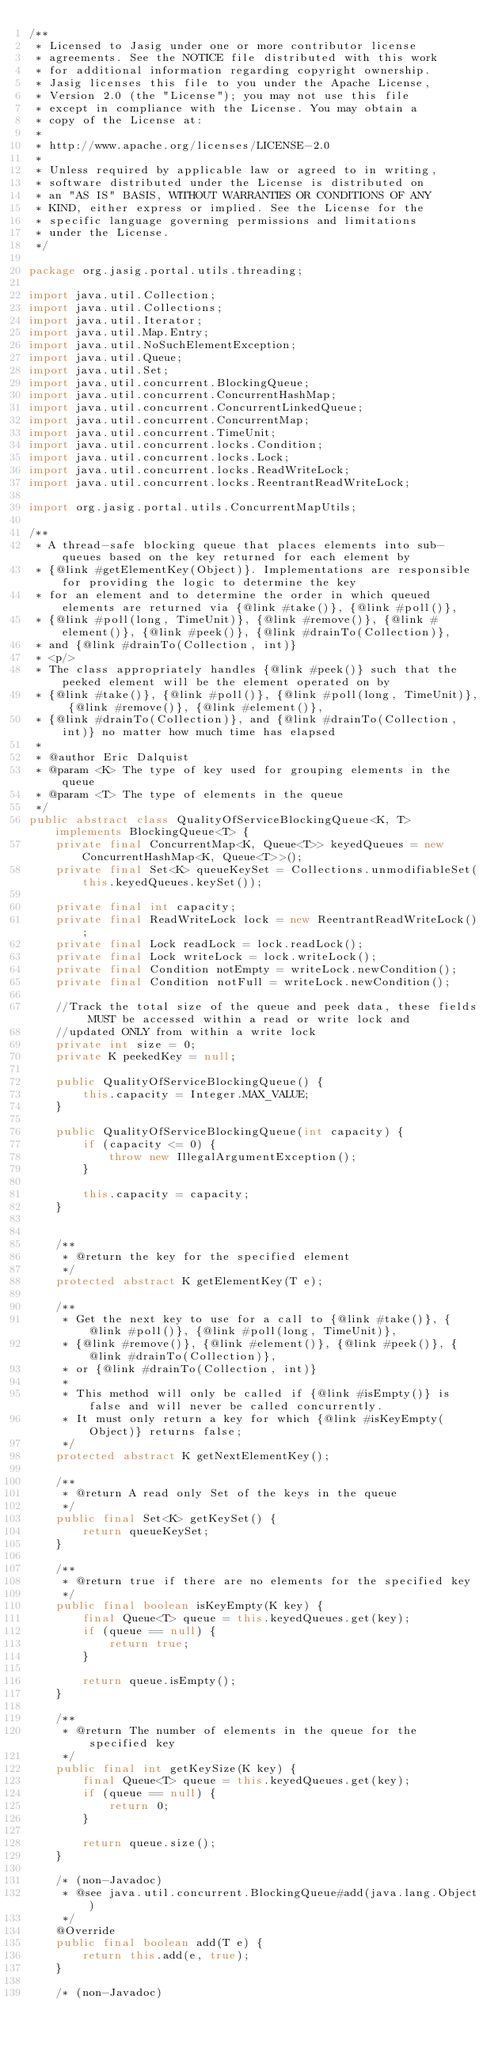<code> <loc_0><loc_0><loc_500><loc_500><_Java_>/**
 * Licensed to Jasig under one or more contributor license
 * agreements. See the NOTICE file distributed with this work
 * for additional information regarding copyright ownership.
 * Jasig licenses this file to you under the Apache License,
 * Version 2.0 (the "License"); you may not use this file
 * except in compliance with the License. You may obtain a
 * copy of the License at:
 *
 * http://www.apache.org/licenses/LICENSE-2.0
 *
 * Unless required by applicable law or agreed to in writing,
 * software distributed under the License is distributed on
 * an "AS IS" BASIS, WITHOUT WARRANTIES OR CONDITIONS OF ANY
 * KIND, either express or implied. See the License for the
 * specific language governing permissions and limitations
 * under the License.
 */

package org.jasig.portal.utils.threading;

import java.util.Collection;
import java.util.Collections;
import java.util.Iterator;
import java.util.Map.Entry;
import java.util.NoSuchElementException;
import java.util.Queue;
import java.util.Set;
import java.util.concurrent.BlockingQueue;
import java.util.concurrent.ConcurrentHashMap;
import java.util.concurrent.ConcurrentLinkedQueue;
import java.util.concurrent.ConcurrentMap;
import java.util.concurrent.TimeUnit;
import java.util.concurrent.locks.Condition;
import java.util.concurrent.locks.Lock;
import java.util.concurrent.locks.ReadWriteLock;
import java.util.concurrent.locks.ReentrantReadWriteLock;

import org.jasig.portal.utils.ConcurrentMapUtils;

/**
 * A thread-safe blocking queue that places elements into sub-queues based on the key returned for each element by
 * {@link #getElementKey(Object)}. Implementations are responsible for providing the logic to determine the key
 * for an element and to determine the order in which queued elements are returned via {@link #take()}, {@link #poll()},
 * {@link #poll(long, TimeUnit)}, {@link #remove()}, {@link #element()}, {@link #peek()}, {@link #drainTo(Collection)}, 
 * and {@link #drainTo(Collection, int)}
 * <p/>
 * The class appropriately handles {@link #peek()} such that the peeked element will be the element operated on by
 * {@link #take()}, {@link #poll()}, {@link #poll(long, TimeUnit)}, {@link #remove()}, {@link #element()},
 * {@link #drainTo(Collection)}, and {@link #drainTo(Collection, int)} no matter how much time has elapsed
 * 
 * @author Eric Dalquist
 * @param <K> The type of key used for grouping elements in the queue
 * @param <T> The type of elements in the queue
 */
public abstract class QualityOfServiceBlockingQueue<K, T> implements BlockingQueue<T> {
    private final ConcurrentMap<K, Queue<T>> keyedQueues = new ConcurrentHashMap<K, Queue<T>>();
    private final Set<K> queueKeySet = Collections.unmodifiableSet(this.keyedQueues.keySet()); 
    
    private final int capacity;
    private final ReadWriteLock lock = new ReentrantReadWriteLock();
    private final Lock readLock = lock.readLock();
    private final Lock writeLock = lock.writeLock();
    private final Condition notEmpty = writeLock.newCondition();
    private final Condition notFull = writeLock.newCondition();
    
    //Track the total size of the queue and peek data, these fields MUST be accessed within a read or write lock and
    //updated ONLY from within a write lock
    private int size = 0;
    private K peekedKey = null;
    
    public QualityOfServiceBlockingQueue() {
        this.capacity = Integer.MAX_VALUE;
    }
    
    public QualityOfServiceBlockingQueue(int capacity) {
        if (capacity <= 0) {
            throw new IllegalArgumentException();
        }
        
        this.capacity = capacity;
    }
    

    /**
     * @return the key for the specified element
     */
    protected abstract K getElementKey(T e);
    
    /**
     * Get the next key to use for a call to {@link #take()}, {@link #poll()}, {@link #poll(long, TimeUnit)},
     * {@link #remove()}, {@link #element()}, {@link #peek()}, {@link #drainTo(Collection)},
     * or {@link #drainTo(Collection, int)}
     * 
     * This method will only be called if {@link #isEmpty()} is false and will never be called concurrently.
     * It must only return a key for which {@link #isKeyEmpty(Object)} returns false;
     */
    protected abstract K getNextElementKey();
    
    /**
     * @return A read only Set of the keys in the queue
     */
    public final Set<K> getKeySet() {
        return queueKeySet;
    }
    
    /**
     * @return true if there are no elements for the specified key
     */
    public final boolean isKeyEmpty(K key) {
        final Queue<T> queue = this.keyedQueues.get(key);
        if (queue == null) {
            return true;
        }
        
        return queue.isEmpty();
    }
    
    /**
     * @return The number of elements in the queue for the specified key
     */
    public final int getKeySize(K key) {
        final Queue<T> queue = this.keyedQueues.get(key);
        if (queue == null) {
            return 0;
        }
        
        return queue.size();
    }

    /* (non-Javadoc)
     * @see java.util.concurrent.BlockingQueue#add(java.lang.Object)
     */
    @Override
    public final boolean add(T e) {
        return this.add(e, true);
    }

    /* (non-Javadoc)</code> 